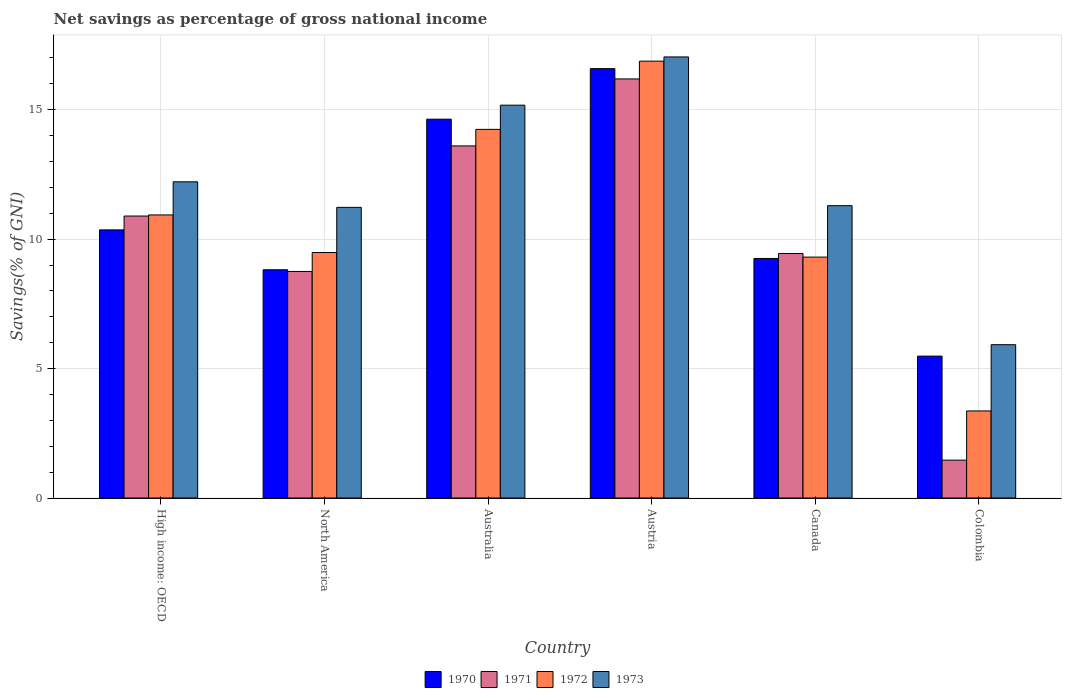How many groups of bars are there?
Your answer should be very brief. 6. Are the number of bars per tick equal to the number of legend labels?
Your response must be concise. Yes. What is the label of the 6th group of bars from the left?
Provide a short and direct response. Colombia. In how many cases, is the number of bars for a given country not equal to the number of legend labels?
Make the answer very short. 0. What is the total savings in 1970 in High income: OECD?
Your answer should be compact. 10.36. Across all countries, what is the maximum total savings in 1971?
Offer a very short reply. 16.19. Across all countries, what is the minimum total savings in 1973?
Keep it short and to the point. 5.92. What is the total total savings in 1970 in the graph?
Provide a succinct answer. 65.13. What is the difference between the total savings in 1970 in Canada and that in High income: OECD?
Ensure brevity in your answer.  -1.1. What is the difference between the total savings in 1970 in Colombia and the total savings in 1972 in High income: OECD?
Ensure brevity in your answer.  -5.45. What is the average total savings in 1970 per country?
Your answer should be compact. 10.86. What is the difference between the total savings of/in 1972 and total savings of/in 1973 in High income: OECD?
Make the answer very short. -1.28. In how many countries, is the total savings in 1972 greater than 14 %?
Offer a very short reply. 2. What is the ratio of the total savings in 1973 in Australia to that in Colombia?
Offer a terse response. 2.56. What is the difference between the highest and the second highest total savings in 1973?
Give a very brief answer. 4.82. What is the difference between the highest and the lowest total savings in 1970?
Your response must be concise. 11.11. In how many countries, is the total savings in 1973 greater than the average total savings in 1973 taken over all countries?
Provide a short and direct response. 3. Is the sum of the total savings in 1973 in Australia and High income: OECD greater than the maximum total savings in 1972 across all countries?
Ensure brevity in your answer.  Yes. What does the 4th bar from the left in Colombia represents?
Offer a terse response. 1973. What does the 3rd bar from the right in Colombia represents?
Your response must be concise. 1971. Is it the case that in every country, the sum of the total savings in 1972 and total savings in 1971 is greater than the total savings in 1973?
Your answer should be very brief. No. Are all the bars in the graph horizontal?
Your answer should be very brief. No. How many countries are there in the graph?
Offer a very short reply. 6. Does the graph contain any zero values?
Keep it short and to the point. No. Does the graph contain grids?
Keep it short and to the point. Yes. How many legend labels are there?
Give a very brief answer. 4. How are the legend labels stacked?
Ensure brevity in your answer.  Horizontal. What is the title of the graph?
Provide a succinct answer. Net savings as percentage of gross national income. What is the label or title of the X-axis?
Your response must be concise. Country. What is the label or title of the Y-axis?
Keep it short and to the point. Savings(% of GNI). What is the Savings(% of GNI) of 1970 in High income: OECD?
Your response must be concise. 10.36. What is the Savings(% of GNI) of 1971 in High income: OECD?
Make the answer very short. 10.89. What is the Savings(% of GNI) of 1972 in High income: OECD?
Offer a very short reply. 10.94. What is the Savings(% of GNI) of 1973 in High income: OECD?
Give a very brief answer. 12.22. What is the Savings(% of GNI) in 1970 in North America?
Give a very brief answer. 8.82. What is the Savings(% of GNI) of 1971 in North America?
Give a very brief answer. 8.75. What is the Savings(% of GNI) of 1972 in North America?
Keep it short and to the point. 9.48. What is the Savings(% of GNI) in 1973 in North America?
Offer a terse response. 11.23. What is the Savings(% of GNI) in 1970 in Australia?
Provide a succinct answer. 14.63. What is the Savings(% of GNI) in 1971 in Australia?
Give a very brief answer. 13.6. What is the Savings(% of GNI) in 1972 in Australia?
Offer a very short reply. 14.24. What is the Savings(% of GNI) of 1973 in Australia?
Keep it short and to the point. 15.18. What is the Savings(% of GNI) in 1970 in Austria?
Your answer should be very brief. 16.59. What is the Savings(% of GNI) in 1971 in Austria?
Make the answer very short. 16.19. What is the Savings(% of GNI) of 1972 in Austria?
Your answer should be very brief. 16.88. What is the Savings(% of GNI) of 1973 in Austria?
Your response must be concise. 17.04. What is the Savings(% of GNI) of 1970 in Canada?
Offer a terse response. 9.25. What is the Savings(% of GNI) of 1971 in Canada?
Your answer should be compact. 9.45. What is the Savings(% of GNI) in 1972 in Canada?
Offer a very short reply. 9.31. What is the Savings(% of GNI) in 1973 in Canada?
Offer a very short reply. 11.29. What is the Savings(% of GNI) in 1970 in Colombia?
Make the answer very short. 5.48. What is the Savings(% of GNI) in 1971 in Colombia?
Keep it short and to the point. 1.46. What is the Savings(% of GNI) of 1972 in Colombia?
Ensure brevity in your answer.  3.36. What is the Savings(% of GNI) of 1973 in Colombia?
Ensure brevity in your answer.  5.92. Across all countries, what is the maximum Savings(% of GNI) of 1970?
Give a very brief answer. 16.59. Across all countries, what is the maximum Savings(% of GNI) of 1971?
Make the answer very short. 16.19. Across all countries, what is the maximum Savings(% of GNI) in 1972?
Offer a very short reply. 16.88. Across all countries, what is the maximum Savings(% of GNI) of 1973?
Your answer should be compact. 17.04. Across all countries, what is the minimum Savings(% of GNI) in 1970?
Keep it short and to the point. 5.48. Across all countries, what is the minimum Savings(% of GNI) in 1971?
Offer a terse response. 1.46. Across all countries, what is the minimum Savings(% of GNI) of 1972?
Ensure brevity in your answer.  3.36. Across all countries, what is the minimum Savings(% of GNI) of 1973?
Ensure brevity in your answer.  5.92. What is the total Savings(% of GNI) in 1970 in the graph?
Ensure brevity in your answer.  65.13. What is the total Savings(% of GNI) of 1971 in the graph?
Your response must be concise. 60.35. What is the total Savings(% of GNI) of 1972 in the graph?
Your answer should be very brief. 64.21. What is the total Savings(% of GNI) of 1973 in the graph?
Your answer should be very brief. 72.88. What is the difference between the Savings(% of GNI) in 1970 in High income: OECD and that in North America?
Provide a short and direct response. 1.54. What is the difference between the Savings(% of GNI) of 1971 in High income: OECD and that in North America?
Offer a very short reply. 2.14. What is the difference between the Savings(% of GNI) in 1972 in High income: OECD and that in North America?
Ensure brevity in your answer.  1.45. What is the difference between the Savings(% of GNI) of 1973 in High income: OECD and that in North America?
Keep it short and to the point. 0.99. What is the difference between the Savings(% of GNI) in 1970 in High income: OECD and that in Australia?
Make the answer very short. -4.28. What is the difference between the Savings(% of GNI) of 1971 in High income: OECD and that in Australia?
Offer a terse response. -2.71. What is the difference between the Savings(% of GNI) of 1972 in High income: OECD and that in Australia?
Provide a short and direct response. -3.31. What is the difference between the Savings(% of GNI) in 1973 in High income: OECD and that in Australia?
Keep it short and to the point. -2.96. What is the difference between the Savings(% of GNI) in 1970 in High income: OECD and that in Austria?
Ensure brevity in your answer.  -6.23. What is the difference between the Savings(% of GNI) in 1971 in High income: OECD and that in Austria?
Your answer should be very brief. -5.3. What is the difference between the Savings(% of GNI) of 1972 in High income: OECD and that in Austria?
Offer a very short reply. -5.94. What is the difference between the Savings(% of GNI) in 1973 in High income: OECD and that in Austria?
Provide a short and direct response. -4.82. What is the difference between the Savings(% of GNI) of 1970 in High income: OECD and that in Canada?
Give a very brief answer. 1.1. What is the difference between the Savings(% of GNI) in 1971 in High income: OECD and that in Canada?
Your answer should be very brief. 1.45. What is the difference between the Savings(% of GNI) in 1972 in High income: OECD and that in Canada?
Give a very brief answer. 1.63. What is the difference between the Savings(% of GNI) in 1973 in High income: OECD and that in Canada?
Your answer should be very brief. 0.92. What is the difference between the Savings(% of GNI) in 1970 in High income: OECD and that in Colombia?
Provide a succinct answer. 4.88. What is the difference between the Savings(% of GNI) in 1971 in High income: OECD and that in Colombia?
Your response must be concise. 9.43. What is the difference between the Savings(% of GNI) in 1972 in High income: OECD and that in Colombia?
Offer a very short reply. 7.57. What is the difference between the Savings(% of GNI) of 1973 in High income: OECD and that in Colombia?
Give a very brief answer. 6.29. What is the difference between the Savings(% of GNI) in 1970 in North America and that in Australia?
Provide a short and direct response. -5.82. What is the difference between the Savings(% of GNI) of 1971 in North America and that in Australia?
Your answer should be compact. -4.85. What is the difference between the Savings(% of GNI) of 1972 in North America and that in Australia?
Your response must be concise. -4.76. What is the difference between the Savings(% of GNI) in 1973 in North America and that in Australia?
Offer a terse response. -3.95. What is the difference between the Savings(% of GNI) of 1970 in North America and that in Austria?
Offer a terse response. -7.77. What is the difference between the Savings(% of GNI) in 1971 in North America and that in Austria?
Keep it short and to the point. -7.44. What is the difference between the Savings(% of GNI) of 1972 in North America and that in Austria?
Offer a terse response. -7.39. What is the difference between the Savings(% of GNI) of 1973 in North America and that in Austria?
Provide a succinct answer. -5.81. What is the difference between the Savings(% of GNI) in 1970 in North America and that in Canada?
Your response must be concise. -0.44. What is the difference between the Savings(% of GNI) in 1971 in North America and that in Canada?
Your answer should be compact. -0.69. What is the difference between the Savings(% of GNI) in 1972 in North America and that in Canada?
Make the answer very short. 0.18. What is the difference between the Savings(% of GNI) in 1973 in North America and that in Canada?
Offer a terse response. -0.07. What is the difference between the Savings(% of GNI) of 1970 in North America and that in Colombia?
Provide a succinct answer. 3.34. What is the difference between the Savings(% of GNI) of 1971 in North America and that in Colombia?
Make the answer very short. 7.29. What is the difference between the Savings(% of GNI) of 1972 in North America and that in Colombia?
Your response must be concise. 6.12. What is the difference between the Savings(% of GNI) of 1973 in North America and that in Colombia?
Your response must be concise. 5.31. What is the difference between the Savings(% of GNI) of 1970 in Australia and that in Austria?
Your response must be concise. -1.95. What is the difference between the Savings(% of GNI) in 1971 in Australia and that in Austria?
Make the answer very short. -2.59. What is the difference between the Savings(% of GNI) in 1972 in Australia and that in Austria?
Provide a succinct answer. -2.64. What is the difference between the Savings(% of GNI) of 1973 in Australia and that in Austria?
Your answer should be compact. -1.86. What is the difference between the Savings(% of GNI) of 1970 in Australia and that in Canada?
Make the answer very short. 5.38. What is the difference between the Savings(% of GNI) in 1971 in Australia and that in Canada?
Keep it short and to the point. 4.16. What is the difference between the Savings(% of GNI) of 1972 in Australia and that in Canada?
Your response must be concise. 4.93. What is the difference between the Savings(% of GNI) in 1973 in Australia and that in Canada?
Keep it short and to the point. 3.88. What is the difference between the Savings(% of GNI) in 1970 in Australia and that in Colombia?
Offer a terse response. 9.15. What is the difference between the Savings(% of GNI) in 1971 in Australia and that in Colombia?
Give a very brief answer. 12.14. What is the difference between the Savings(% of GNI) of 1972 in Australia and that in Colombia?
Make the answer very short. 10.88. What is the difference between the Savings(% of GNI) of 1973 in Australia and that in Colombia?
Provide a succinct answer. 9.25. What is the difference between the Savings(% of GNI) of 1970 in Austria and that in Canada?
Offer a terse response. 7.33. What is the difference between the Savings(% of GNI) of 1971 in Austria and that in Canada?
Your answer should be very brief. 6.74. What is the difference between the Savings(% of GNI) of 1972 in Austria and that in Canada?
Keep it short and to the point. 7.57. What is the difference between the Savings(% of GNI) in 1973 in Austria and that in Canada?
Offer a very short reply. 5.75. What is the difference between the Savings(% of GNI) in 1970 in Austria and that in Colombia?
Give a very brief answer. 11.11. What is the difference between the Savings(% of GNI) of 1971 in Austria and that in Colombia?
Make the answer very short. 14.73. What is the difference between the Savings(% of GNI) of 1972 in Austria and that in Colombia?
Your response must be concise. 13.51. What is the difference between the Savings(% of GNI) in 1973 in Austria and that in Colombia?
Your answer should be very brief. 11.12. What is the difference between the Savings(% of GNI) of 1970 in Canada and that in Colombia?
Give a very brief answer. 3.77. What is the difference between the Savings(% of GNI) in 1971 in Canada and that in Colombia?
Offer a terse response. 7.98. What is the difference between the Savings(% of GNI) in 1972 in Canada and that in Colombia?
Keep it short and to the point. 5.94. What is the difference between the Savings(% of GNI) in 1973 in Canada and that in Colombia?
Make the answer very short. 5.37. What is the difference between the Savings(% of GNI) of 1970 in High income: OECD and the Savings(% of GNI) of 1971 in North America?
Give a very brief answer. 1.61. What is the difference between the Savings(% of GNI) of 1970 in High income: OECD and the Savings(% of GNI) of 1972 in North America?
Offer a very short reply. 0.87. What is the difference between the Savings(% of GNI) of 1970 in High income: OECD and the Savings(% of GNI) of 1973 in North America?
Give a very brief answer. -0.87. What is the difference between the Savings(% of GNI) in 1971 in High income: OECD and the Savings(% of GNI) in 1972 in North America?
Provide a short and direct response. 1.41. What is the difference between the Savings(% of GNI) of 1971 in High income: OECD and the Savings(% of GNI) of 1973 in North America?
Provide a succinct answer. -0.34. What is the difference between the Savings(% of GNI) in 1972 in High income: OECD and the Savings(% of GNI) in 1973 in North America?
Provide a succinct answer. -0.29. What is the difference between the Savings(% of GNI) of 1970 in High income: OECD and the Savings(% of GNI) of 1971 in Australia?
Provide a succinct answer. -3.24. What is the difference between the Savings(% of GNI) of 1970 in High income: OECD and the Savings(% of GNI) of 1972 in Australia?
Make the answer very short. -3.88. What is the difference between the Savings(% of GNI) in 1970 in High income: OECD and the Savings(% of GNI) in 1973 in Australia?
Offer a very short reply. -4.82. What is the difference between the Savings(% of GNI) of 1971 in High income: OECD and the Savings(% of GNI) of 1972 in Australia?
Give a very brief answer. -3.35. What is the difference between the Savings(% of GNI) in 1971 in High income: OECD and the Savings(% of GNI) in 1973 in Australia?
Make the answer very short. -4.28. What is the difference between the Savings(% of GNI) of 1972 in High income: OECD and the Savings(% of GNI) of 1973 in Australia?
Give a very brief answer. -4.24. What is the difference between the Savings(% of GNI) of 1970 in High income: OECD and the Savings(% of GNI) of 1971 in Austria?
Keep it short and to the point. -5.83. What is the difference between the Savings(% of GNI) of 1970 in High income: OECD and the Savings(% of GNI) of 1972 in Austria?
Make the answer very short. -6.52. What is the difference between the Savings(% of GNI) of 1970 in High income: OECD and the Savings(% of GNI) of 1973 in Austria?
Ensure brevity in your answer.  -6.68. What is the difference between the Savings(% of GNI) of 1971 in High income: OECD and the Savings(% of GNI) of 1972 in Austria?
Make the answer very short. -5.98. What is the difference between the Savings(% of GNI) of 1971 in High income: OECD and the Savings(% of GNI) of 1973 in Austria?
Offer a terse response. -6.15. What is the difference between the Savings(% of GNI) in 1972 in High income: OECD and the Savings(% of GNI) in 1973 in Austria?
Your answer should be compact. -6.1. What is the difference between the Savings(% of GNI) of 1970 in High income: OECD and the Savings(% of GNI) of 1971 in Canada?
Provide a short and direct response. 0.91. What is the difference between the Savings(% of GNI) in 1970 in High income: OECD and the Savings(% of GNI) in 1972 in Canada?
Your answer should be very brief. 1.05. What is the difference between the Savings(% of GNI) in 1970 in High income: OECD and the Savings(% of GNI) in 1973 in Canada?
Your answer should be very brief. -0.94. What is the difference between the Savings(% of GNI) in 1971 in High income: OECD and the Savings(% of GNI) in 1972 in Canada?
Your response must be concise. 1.59. What is the difference between the Savings(% of GNI) of 1971 in High income: OECD and the Savings(% of GNI) of 1973 in Canada?
Ensure brevity in your answer.  -0.4. What is the difference between the Savings(% of GNI) in 1972 in High income: OECD and the Savings(% of GNI) in 1973 in Canada?
Make the answer very short. -0.36. What is the difference between the Savings(% of GNI) in 1970 in High income: OECD and the Savings(% of GNI) in 1971 in Colombia?
Offer a very short reply. 8.9. What is the difference between the Savings(% of GNI) of 1970 in High income: OECD and the Savings(% of GNI) of 1972 in Colombia?
Your response must be concise. 6.99. What is the difference between the Savings(% of GNI) in 1970 in High income: OECD and the Savings(% of GNI) in 1973 in Colombia?
Make the answer very short. 4.44. What is the difference between the Savings(% of GNI) of 1971 in High income: OECD and the Savings(% of GNI) of 1972 in Colombia?
Give a very brief answer. 7.53. What is the difference between the Savings(% of GNI) of 1971 in High income: OECD and the Savings(% of GNI) of 1973 in Colombia?
Keep it short and to the point. 4.97. What is the difference between the Savings(% of GNI) of 1972 in High income: OECD and the Savings(% of GNI) of 1973 in Colombia?
Provide a short and direct response. 5.01. What is the difference between the Savings(% of GNI) of 1970 in North America and the Savings(% of GNI) of 1971 in Australia?
Keep it short and to the point. -4.78. What is the difference between the Savings(% of GNI) of 1970 in North America and the Savings(% of GNI) of 1972 in Australia?
Your answer should be very brief. -5.42. What is the difference between the Savings(% of GNI) in 1970 in North America and the Savings(% of GNI) in 1973 in Australia?
Your answer should be very brief. -6.36. What is the difference between the Savings(% of GNI) in 1971 in North America and the Savings(% of GNI) in 1972 in Australia?
Keep it short and to the point. -5.49. What is the difference between the Savings(% of GNI) of 1971 in North America and the Savings(% of GNI) of 1973 in Australia?
Make the answer very short. -6.42. What is the difference between the Savings(% of GNI) in 1972 in North America and the Savings(% of GNI) in 1973 in Australia?
Provide a short and direct response. -5.69. What is the difference between the Savings(% of GNI) in 1970 in North America and the Savings(% of GNI) in 1971 in Austria?
Ensure brevity in your answer.  -7.37. What is the difference between the Savings(% of GNI) in 1970 in North America and the Savings(% of GNI) in 1972 in Austria?
Your answer should be very brief. -8.06. What is the difference between the Savings(% of GNI) of 1970 in North America and the Savings(% of GNI) of 1973 in Austria?
Make the answer very short. -8.22. What is the difference between the Savings(% of GNI) in 1971 in North America and the Savings(% of GNI) in 1972 in Austria?
Make the answer very short. -8.12. What is the difference between the Savings(% of GNI) in 1971 in North America and the Savings(% of GNI) in 1973 in Austria?
Offer a very short reply. -8.29. What is the difference between the Savings(% of GNI) of 1972 in North America and the Savings(% of GNI) of 1973 in Austria?
Offer a terse response. -7.56. What is the difference between the Savings(% of GNI) in 1970 in North America and the Savings(% of GNI) in 1971 in Canada?
Offer a terse response. -0.63. What is the difference between the Savings(% of GNI) of 1970 in North America and the Savings(% of GNI) of 1972 in Canada?
Offer a very short reply. -0.49. What is the difference between the Savings(% of GNI) in 1970 in North America and the Savings(% of GNI) in 1973 in Canada?
Provide a short and direct response. -2.48. What is the difference between the Savings(% of GNI) in 1971 in North America and the Savings(% of GNI) in 1972 in Canada?
Your answer should be very brief. -0.55. What is the difference between the Savings(% of GNI) of 1971 in North America and the Savings(% of GNI) of 1973 in Canada?
Your response must be concise. -2.54. What is the difference between the Savings(% of GNI) in 1972 in North America and the Savings(% of GNI) in 1973 in Canada?
Keep it short and to the point. -1.81. What is the difference between the Savings(% of GNI) in 1970 in North America and the Savings(% of GNI) in 1971 in Colombia?
Your response must be concise. 7.36. What is the difference between the Savings(% of GNI) of 1970 in North America and the Savings(% of GNI) of 1972 in Colombia?
Offer a very short reply. 5.45. What is the difference between the Savings(% of GNI) in 1970 in North America and the Savings(% of GNI) in 1973 in Colombia?
Offer a very short reply. 2.89. What is the difference between the Savings(% of GNI) of 1971 in North America and the Savings(% of GNI) of 1972 in Colombia?
Your answer should be very brief. 5.39. What is the difference between the Savings(% of GNI) of 1971 in North America and the Savings(% of GNI) of 1973 in Colombia?
Offer a very short reply. 2.83. What is the difference between the Savings(% of GNI) in 1972 in North America and the Savings(% of GNI) in 1973 in Colombia?
Offer a very short reply. 3.56. What is the difference between the Savings(% of GNI) in 1970 in Australia and the Savings(% of GNI) in 1971 in Austria?
Provide a succinct answer. -1.55. What is the difference between the Savings(% of GNI) of 1970 in Australia and the Savings(% of GNI) of 1972 in Austria?
Provide a succinct answer. -2.24. What is the difference between the Savings(% of GNI) of 1970 in Australia and the Savings(% of GNI) of 1973 in Austria?
Make the answer very short. -2.4. What is the difference between the Savings(% of GNI) in 1971 in Australia and the Savings(% of GNI) in 1972 in Austria?
Offer a terse response. -3.27. What is the difference between the Savings(% of GNI) of 1971 in Australia and the Savings(% of GNI) of 1973 in Austria?
Your answer should be very brief. -3.44. What is the difference between the Savings(% of GNI) of 1972 in Australia and the Savings(% of GNI) of 1973 in Austria?
Offer a very short reply. -2.8. What is the difference between the Savings(% of GNI) of 1970 in Australia and the Savings(% of GNI) of 1971 in Canada?
Make the answer very short. 5.19. What is the difference between the Savings(% of GNI) in 1970 in Australia and the Savings(% of GNI) in 1972 in Canada?
Offer a very short reply. 5.33. What is the difference between the Savings(% of GNI) in 1970 in Australia and the Savings(% of GNI) in 1973 in Canada?
Offer a very short reply. 3.34. What is the difference between the Savings(% of GNI) in 1971 in Australia and the Savings(% of GNI) in 1972 in Canada?
Your response must be concise. 4.3. What is the difference between the Savings(% of GNI) of 1971 in Australia and the Savings(% of GNI) of 1973 in Canada?
Your answer should be compact. 2.31. What is the difference between the Savings(% of GNI) in 1972 in Australia and the Savings(% of GNI) in 1973 in Canada?
Give a very brief answer. 2.95. What is the difference between the Savings(% of GNI) in 1970 in Australia and the Savings(% of GNI) in 1971 in Colombia?
Your answer should be very brief. 13.17. What is the difference between the Savings(% of GNI) in 1970 in Australia and the Savings(% of GNI) in 1972 in Colombia?
Your answer should be very brief. 11.27. What is the difference between the Savings(% of GNI) of 1970 in Australia and the Savings(% of GNI) of 1973 in Colombia?
Keep it short and to the point. 8.71. What is the difference between the Savings(% of GNI) of 1971 in Australia and the Savings(% of GNI) of 1972 in Colombia?
Keep it short and to the point. 10.24. What is the difference between the Savings(% of GNI) of 1971 in Australia and the Savings(% of GNI) of 1973 in Colombia?
Your answer should be very brief. 7.68. What is the difference between the Savings(% of GNI) of 1972 in Australia and the Savings(% of GNI) of 1973 in Colombia?
Your response must be concise. 8.32. What is the difference between the Savings(% of GNI) in 1970 in Austria and the Savings(% of GNI) in 1971 in Canada?
Your answer should be compact. 7.14. What is the difference between the Savings(% of GNI) in 1970 in Austria and the Savings(% of GNI) in 1972 in Canada?
Offer a terse response. 7.28. What is the difference between the Savings(% of GNI) of 1970 in Austria and the Savings(% of GNI) of 1973 in Canada?
Give a very brief answer. 5.29. What is the difference between the Savings(% of GNI) of 1971 in Austria and the Savings(% of GNI) of 1972 in Canada?
Offer a terse response. 6.88. What is the difference between the Savings(% of GNI) of 1971 in Austria and the Savings(% of GNI) of 1973 in Canada?
Make the answer very short. 4.9. What is the difference between the Savings(% of GNI) in 1972 in Austria and the Savings(% of GNI) in 1973 in Canada?
Your answer should be very brief. 5.58. What is the difference between the Savings(% of GNI) of 1970 in Austria and the Savings(% of GNI) of 1971 in Colombia?
Your answer should be very brief. 15.12. What is the difference between the Savings(% of GNI) in 1970 in Austria and the Savings(% of GNI) in 1972 in Colombia?
Provide a succinct answer. 13.22. What is the difference between the Savings(% of GNI) of 1970 in Austria and the Savings(% of GNI) of 1973 in Colombia?
Make the answer very short. 10.66. What is the difference between the Savings(% of GNI) in 1971 in Austria and the Savings(% of GNI) in 1972 in Colombia?
Provide a succinct answer. 12.83. What is the difference between the Savings(% of GNI) of 1971 in Austria and the Savings(% of GNI) of 1973 in Colombia?
Offer a terse response. 10.27. What is the difference between the Savings(% of GNI) of 1972 in Austria and the Savings(% of GNI) of 1973 in Colombia?
Your answer should be compact. 10.95. What is the difference between the Savings(% of GNI) of 1970 in Canada and the Savings(% of GNI) of 1971 in Colombia?
Your answer should be very brief. 7.79. What is the difference between the Savings(% of GNI) of 1970 in Canada and the Savings(% of GNI) of 1972 in Colombia?
Your response must be concise. 5.89. What is the difference between the Savings(% of GNI) of 1970 in Canada and the Savings(% of GNI) of 1973 in Colombia?
Make the answer very short. 3.33. What is the difference between the Savings(% of GNI) in 1971 in Canada and the Savings(% of GNI) in 1972 in Colombia?
Your answer should be very brief. 6.08. What is the difference between the Savings(% of GNI) of 1971 in Canada and the Savings(% of GNI) of 1973 in Colombia?
Make the answer very short. 3.52. What is the difference between the Savings(% of GNI) of 1972 in Canada and the Savings(% of GNI) of 1973 in Colombia?
Offer a very short reply. 3.38. What is the average Savings(% of GNI) of 1970 per country?
Offer a terse response. 10.86. What is the average Savings(% of GNI) of 1971 per country?
Offer a terse response. 10.06. What is the average Savings(% of GNI) in 1972 per country?
Make the answer very short. 10.7. What is the average Savings(% of GNI) of 1973 per country?
Make the answer very short. 12.15. What is the difference between the Savings(% of GNI) of 1970 and Savings(% of GNI) of 1971 in High income: OECD?
Ensure brevity in your answer.  -0.53. What is the difference between the Savings(% of GNI) in 1970 and Savings(% of GNI) in 1972 in High income: OECD?
Your response must be concise. -0.58. What is the difference between the Savings(% of GNI) in 1970 and Savings(% of GNI) in 1973 in High income: OECD?
Make the answer very short. -1.86. What is the difference between the Savings(% of GNI) in 1971 and Savings(% of GNI) in 1972 in High income: OECD?
Keep it short and to the point. -0.04. What is the difference between the Savings(% of GNI) in 1971 and Savings(% of GNI) in 1973 in High income: OECD?
Your answer should be compact. -1.32. What is the difference between the Savings(% of GNI) of 1972 and Savings(% of GNI) of 1973 in High income: OECD?
Provide a short and direct response. -1.28. What is the difference between the Savings(% of GNI) in 1970 and Savings(% of GNI) in 1971 in North America?
Provide a succinct answer. 0.07. What is the difference between the Savings(% of GNI) in 1970 and Savings(% of GNI) in 1972 in North America?
Offer a very short reply. -0.67. What is the difference between the Savings(% of GNI) in 1970 and Savings(% of GNI) in 1973 in North America?
Provide a short and direct response. -2.41. What is the difference between the Savings(% of GNI) of 1971 and Savings(% of GNI) of 1972 in North America?
Provide a short and direct response. -0.73. What is the difference between the Savings(% of GNI) of 1971 and Savings(% of GNI) of 1973 in North America?
Provide a succinct answer. -2.48. What is the difference between the Savings(% of GNI) in 1972 and Savings(% of GNI) in 1973 in North America?
Offer a terse response. -1.74. What is the difference between the Savings(% of GNI) of 1970 and Savings(% of GNI) of 1971 in Australia?
Give a very brief answer. 1.03. What is the difference between the Savings(% of GNI) in 1970 and Savings(% of GNI) in 1972 in Australia?
Your answer should be very brief. 0.39. What is the difference between the Savings(% of GNI) in 1970 and Savings(% of GNI) in 1973 in Australia?
Ensure brevity in your answer.  -0.54. What is the difference between the Savings(% of GNI) in 1971 and Savings(% of GNI) in 1972 in Australia?
Keep it short and to the point. -0.64. What is the difference between the Savings(% of GNI) in 1971 and Savings(% of GNI) in 1973 in Australia?
Offer a terse response. -1.57. What is the difference between the Savings(% of GNI) in 1972 and Savings(% of GNI) in 1973 in Australia?
Offer a terse response. -0.93. What is the difference between the Savings(% of GNI) in 1970 and Savings(% of GNI) in 1971 in Austria?
Keep it short and to the point. 0.4. What is the difference between the Savings(% of GNI) in 1970 and Savings(% of GNI) in 1972 in Austria?
Provide a succinct answer. -0.29. What is the difference between the Savings(% of GNI) of 1970 and Savings(% of GNI) of 1973 in Austria?
Your response must be concise. -0.45. What is the difference between the Savings(% of GNI) in 1971 and Savings(% of GNI) in 1972 in Austria?
Your answer should be compact. -0.69. What is the difference between the Savings(% of GNI) of 1971 and Savings(% of GNI) of 1973 in Austria?
Ensure brevity in your answer.  -0.85. What is the difference between the Savings(% of GNI) in 1972 and Savings(% of GNI) in 1973 in Austria?
Ensure brevity in your answer.  -0.16. What is the difference between the Savings(% of GNI) of 1970 and Savings(% of GNI) of 1971 in Canada?
Provide a succinct answer. -0.19. What is the difference between the Savings(% of GNI) in 1970 and Savings(% of GNI) in 1972 in Canada?
Your answer should be very brief. -0.05. What is the difference between the Savings(% of GNI) of 1970 and Savings(% of GNI) of 1973 in Canada?
Keep it short and to the point. -2.04. What is the difference between the Savings(% of GNI) of 1971 and Savings(% of GNI) of 1972 in Canada?
Your answer should be very brief. 0.14. What is the difference between the Savings(% of GNI) in 1971 and Savings(% of GNI) in 1973 in Canada?
Make the answer very short. -1.85. What is the difference between the Savings(% of GNI) in 1972 and Savings(% of GNI) in 1973 in Canada?
Offer a terse response. -1.99. What is the difference between the Savings(% of GNI) of 1970 and Savings(% of GNI) of 1971 in Colombia?
Provide a succinct answer. 4.02. What is the difference between the Savings(% of GNI) in 1970 and Savings(% of GNI) in 1972 in Colombia?
Make the answer very short. 2.12. What is the difference between the Savings(% of GNI) of 1970 and Savings(% of GNI) of 1973 in Colombia?
Provide a short and direct response. -0.44. What is the difference between the Savings(% of GNI) in 1971 and Savings(% of GNI) in 1972 in Colombia?
Make the answer very short. -1.9. What is the difference between the Savings(% of GNI) in 1971 and Savings(% of GNI) in 1973 in Colombia?
Provide a short and direct response. -4.46. What is the difference between the Savings(% of GNI) of 1972 and Savings(% of GNI) of 1973 in Colombia?
Your answer should be very brief. -2.56. What is the ratio of the Savings(% of GNI) of 1970 in High income: OECD to that in North America?
Ensure brevity in your answer.  1.17. What is the ratio of the Savings(% of GNI) of 1971 in High income: OECD to that in North America?
Make the answer very short. 1.24. What is the ratio of the Savings(% of GNI) in 1972 in High income: OECD to that in North America?
Make the answer very short. 1.15. What is the ratio of the Savings(% of GNI) in 1973 in High income: OECD to that in North America?
Offer a very short reply. 1.09. What is the ratio of the Savings(% of GNI) in 1970 in High income: OECD to that in Australia?
Provide a succinct answer. 0.71. What is the ratio of the Savings(% of GNI) in 1971 in High income: OECD to that in Australia?
Your response must be concise. 0.8. What is the ratio of the Savings(% of GNI) of 1972 in High income: OECD to that in Australia?
Your response must be concise. 0.77. What is the ratio of the Savings(% of GNI) of 1973 in High income: OECD to that in Australia?
Ensure brevity in your answer.  0.8. What is the ratio of the Savings(% of GNI) in 1970 in High income: OECD to that in Austria?
Ensure brevity in your answer.  0.62. What is the ratio of the Savings(% of GNI) in 1971 in High income: OECD to that in Austria?
Your answer should be very brief. 0.67. What is the ratio of the Savings(% of GNI) in 1972 in High income: OECD to that in Austria?
Give a very brief answer. 0.65. What is the ratio of the Savings(% of GNI) of 1973 in High income: OECD to that in Austria?
Your answer should be very brief. 0.72. What is the ratio of the Savings(% of GNI) in 1970 in High income: OECD to that in Canada?
Your answer should be compact. 1.12. What is the ratio of the Savings(% of GNI) in 1971 in High income: OECD to that in Canada?
Your response must be concise. 1.15. What is the ratio of the Savings(% of GNI) in 1972 in High income: OECD to that in Canada?
Make the answer very short. 1.18. What is the ratio of the Savings(% of GNI) in 1973 in High income: OECD to that in Canada?
Offer a terse response. 1.08. What is the ratio of the Savings(% of GNI) in 1970 in High income: OECD to that in Colombia?
Give a very brief answer. 1.89. What is the ratio of the Savings(% of GNI) of 1971 in High income: OECD to that in Colombia?
Provide a short and direct response. 7.45. What is the ratio of the Savings(% of GNI) in 1972 in High income: OECD to that in Colombia?
Your answer should be compact. 3.25. What is the ratio of the Savings(% of GNI) in 1973 in High income: OECD to that in Colombia?
Provide a short and direct response. 2.06. What is the ratio of the Savings(% of GNI) in 1970 in North America to that in Australia?
Provide a succinct answer. 0.6. What is the ratio of the Savings(% of GNI) in 1971 in North America to that in Australia?
Give a very brief answer. 0.64. What is the ratio of the Savings(% of GNI) in 1972 in North America to that in Australia?
Your answer should be compact. 0.67. What is the ratio of the Savings(% of GNI) in 1973 in North America to that in Australia?
Offer a terse response. 0.74. What is the ratio of the Savings(% of GNI) in 1970 in North America to that in Austria?
Give a very brief answer. 0.53. What is the ratio of the Savings(% of GNI) in 1971 in North America to that in Austria?
Provide a succinct answer. 0.54. What is the ratio of the Savings(% of GNI) in 1972 in North America to that in Austria?
Your answer should be compact. 0.56. What is the ratio of the Savings(% of GNI) in 1973 in North America to that in Austria?
Offer a terse response. 0.66. What is the ratio of the Savings(% of GNI) in 1970 in North America to that in Canada?
Your answer should be compact. 0.95. What is the ratio of the Savings(% of GNI) in 1971 in North America to that in Canada?
Provide a short and direct response. 0.93. What is the ratio of the Savings(% of GNI) of 1972 in North America to that in Canada?
Provide a short and direct response. 1.02. What is the ratio of the Savings(% of GNI) in 1970 in North America to that in Colombia?
Keep it short and to the point. 1.61. What is the ratio of the Savings(% of GNI) in 1971 in North America to that in Colombia?
Your response must be concise. 5.98. What is the ratio of the Savings(% of GNI) in 1972 in North America to that in Colombia?
Give a very brief answer. 2.82. What is the ratio of the Savings(% of GNI) in 1973 in North America to that in Colombia?
Make the answer very short. 1.9. What is the ratio of the Savings(% of GNI) of 1970 in Australia to that in Austria?
Offer a very short reply. 0.88. What is the ratio of the Savings(% of GNI) of 1971 in Australia to that in Austria?
Offer a terse response. 0.84. What is the ratio of the Savings(% of GNI) of 1972 in Australia to that in Austria?
Make the answer very short. 0.84. What is the ratio of the Savings(% of GNI) in 1973 in Australia to that in Austria?
Ensure brevity in your answer.  0.89. What is the ratio of the Savings(% of GNI) of 1970 in Australia to that in Canada?
Offer a terse response. 1.58. What is the ratio of the Savings(% of GNI) in 1971 in Australia to that in Canada?
Your answer should be very brief. 1.44. What is the ratio of the Savings(% of GNI) in 1972 in Australia to that in Canada?
Offer a terse response. 1.53. What is the ratio of the Savings(% of GNI) in 1973 in Australia to that in Canada?
Keep it short and to the point. 1.34. What is the ratio of the Savings(% of GNI) of 1970 in Australia to that in Colombia?
Ensure brevity in your answer.  2.67. What is the ratio of the Savings(% of GNI) in 1971 in Australia to that in Colombia?
Your response must be concise. 9.3. What is the ratio of the Savings(% of GNI) of 1972 in Australia to that in Colombia?
Your answer should be compact. 4.23. What is the ratio of the Savings(% of GNI) of 1973 in Australia to that in Colombia?
Make the answer very short. 2.56. What is the ratio of the Savings(% of GNI) of 1970 in Austria to that in Canada?
Your response must be concise. 1.79. What is the ratio of the Savings(% of GNI) in 1971 in Austria to that in Canada?
Your answer should be very brief. 1.71. What is the ratio of the Savings(% of GNI) of 1972 in Austria to that in Canada?
Offer a very short reply. 1.81. What is the ratio of the Savings(% of GNI) in 1973 in Austria to that in Canada?
Your answer should be very brief. 1.51. What is the ratio of the Savings(% of GNI) in 1970 in Austria to that in Colombia?
Provide a succinct answer. 3.03. What is the ratio of the Savings(% of GNI) in 1971 in Austria to that in Colombia?
Give a very brief answer. 11.07. What is the ratio of the Savings(% of GNI) of 1972 in Austria to that in Colombia?
Your response must be concise. 5.02. What is the ratio of the Savings(% of GNI) of 1973 in Austria to that in Colombia?
Ensure brevity in your answer.  2.88. What is the ratio of the Savings(% of GNI) in 1970 in Canada to that in Colombia?
Offer a very short reply. 1.69. What is the ratio of the Savings(% of GNI) of 1971 in Canada to that in Colombia?
Provide a short and direct response. 6.46. What is the ratio of the Savings(% of GNI) in 1972 in Canada to that in Colombia?
Offer a very short reply. 2.77. What is the ratio of the Savings(% of GNI) in 1973 in Canada to that in Colombia?
Offer a very short reply. 1.91. What is the difference between the highest and the second highest Savings(% of GNI) in 1970?
Provide a short and direct response. 1.95. What is the difference between the highest and the second highest Savings(% of GNI) of 1971?
Ensure brevity in your answer.  2.59. What is the difference between the highest and the second highest Savings(% of GNI) of 1972?
Offer a terse response. 2.64. What is the difference between the highest and the second highest Savings(% of GNI) in 1973?
Your response must be concise. 1.86. What is the difference between the highest and the lowest Savings(% of GNI) of 1970?
Give a very brief answer. 11.11. What is the difference between the highest and the lowest Savings(% of GNI) of 1971?
Keep it short and to the point. 14.73. What is the difference between the highest and the lowest Savings(% of GNI) of 1972?
Offer a very short reply. 13.51. What is the difference between the highest and the lowest Savings(% of GNI) of 1973?
Give a very brief answer. 11.12. 